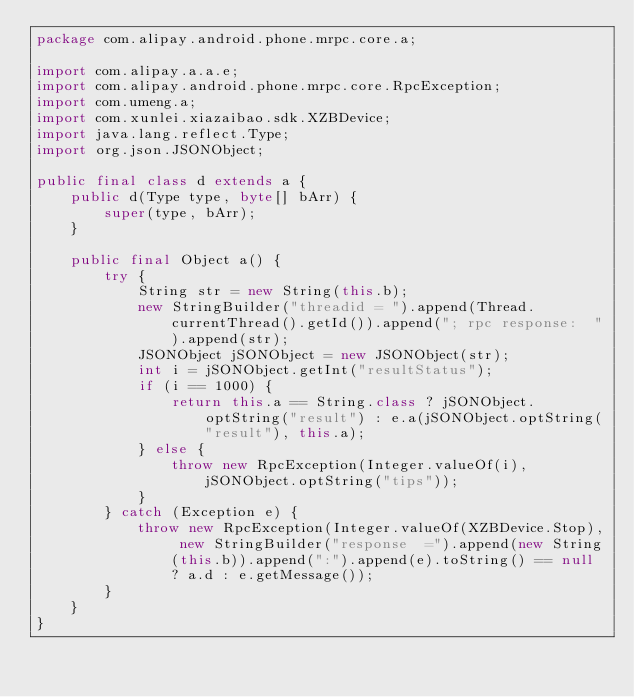<code> <loc_0><loc_0><loc_500><loc_500><_Java_>package com.alipay.android.phone.mrpc.core.a;

import com.alipay.a.a.e;
import com.alipay.android.phone.mrpc.core.RpcException;
import com.umeng.a;
import com.xunlei.xiazaibao.sdk.XZBDevice;
import java.lang.reflect.Type;
import org.json.JSONObject;

public final class d extends a {
    public d(Type type, byte[] bArr) {
        super(type, bArr);
    }

    public final Object a() {
        try {
            String str = new String(this.b);
            new StringBuilder("threadid = ").append(Thread.currentThread().getId()).append("; rpc response:  ").append(str);
            JSONObject jSONObject = new JSONObject(str);
            int i = jSONObject.getInt("resultStatus");
            if (i == 1000) {
                return this.a == String.class ? jSONObject.optString("result") : e.a(jSONObject.optString("result"), this.a);
            } else {
                throw new RpcException(Integer.valueOf(i), jSONObject.optString("tips"));
            }
        } catch (Exception e) {
            throw new RpcException(Integer.valueOf(XZBDevice.Stop), new StringBuilder("response  =").append(new String(this.b)).append(":").append(e).toString() == null ? a.d : e.getMessage());
        }
    }
}
</code> 